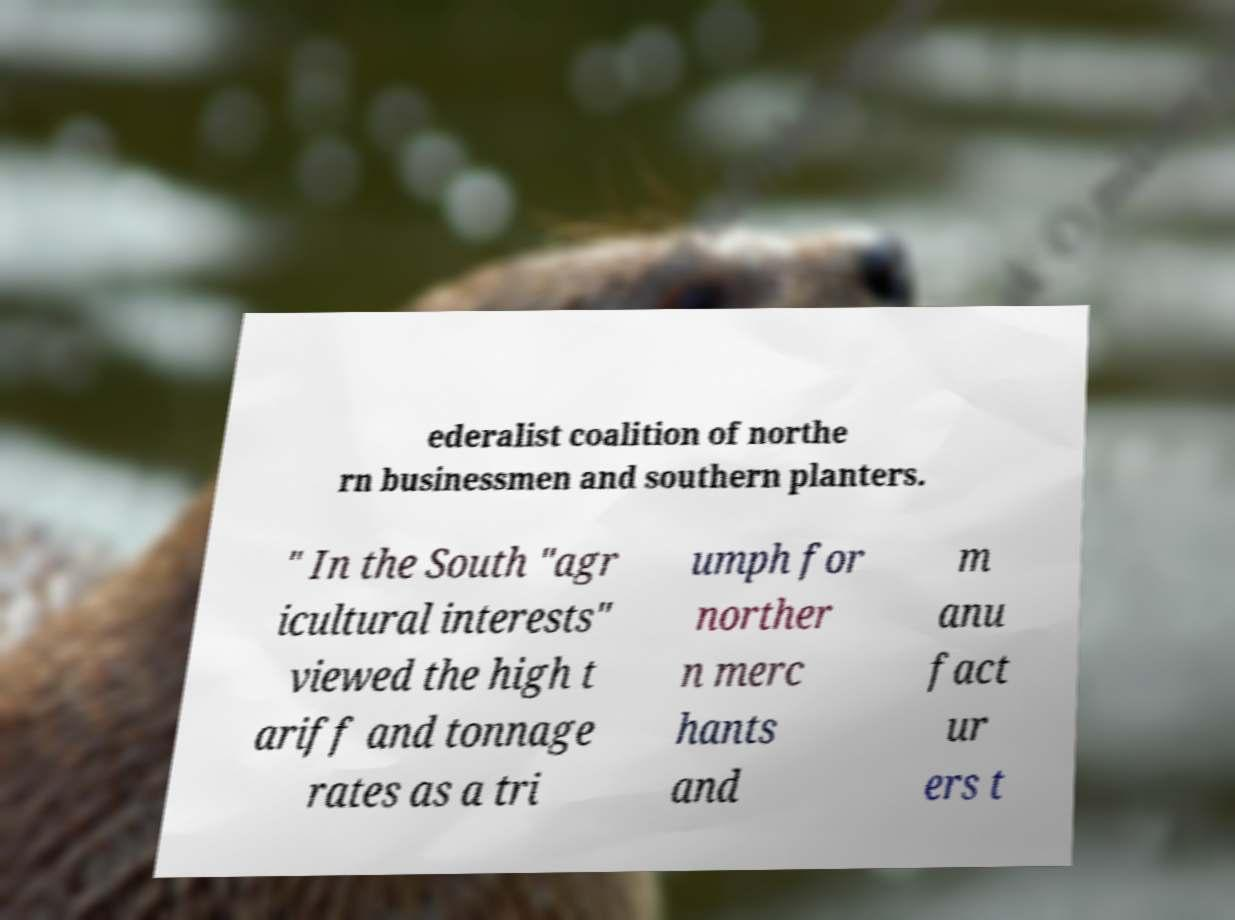I need the written content from this picture converted into text. Can you do that? ederalist coalition of northe rn businessmen and southern planters. " In the South "agr icultural interests" viewed the high t ariff and tonnage rates as a tri umph for norther n merc hants and m anu fact ur ers t 